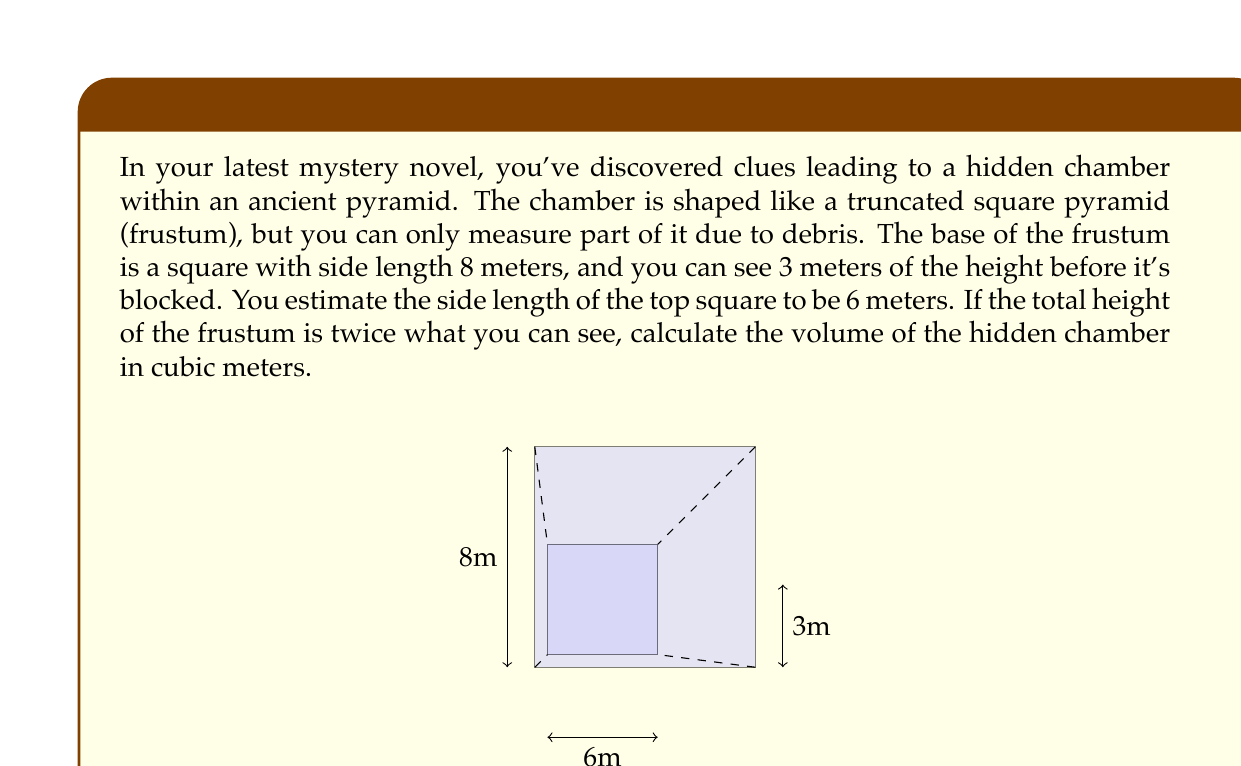Could you help me with this problem? Let's approach this step-by-step:

1) The formula for the volume of a frustum is:

   $$V = \frac{1}{3}h(a^2 + ab + b^2)$$

   where $h$ is the height, $a$ is the side length of the base, and $b$ is the side length of the top.

2) We're given:
   - Base side length $a = 8$ meters
   - Top side length $b = 6$ meters
   - Visible height = 3 meters
   - Total height $h$ is twice the visible height, so $h = 3 \times 2 = 6$ meters

3) Let's substitute these values into our formula:

   $$V = \frac{1}{3} \times 6 (8^2 + 8 \times 6 + 6^2)$$

4) Simplify the expression inside the parentheses:

   $$V = 2(64 + 48 + 36)$$

5) Add the numbers inside the parentheses:

   $$V = 2(148)$$

6) Multiply:

   $$V = 296$$

Therefore, the volume of the hidden chamber is 296 cubic meters.
Answer: 296 m³ 